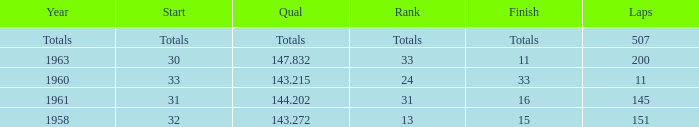Parse the table in full. {'header': ['Year', 'Start', 'Qual', 'Rank', 'Finish', 'Laps'], 'rows': [['Totals', 'Totals', 'Totals', 'Totals', 'Totals', '507'], ['1963', '30', '147.832', '33', '11', '200'], ['1960', '33', '143.215', '24', '33', '11'], ['1961', '31', '144.202', '31', '16', '145'], ['1958', '32', '143.272', '13', '15', '151']]} What's the Finish rank of 31? 16.0. 